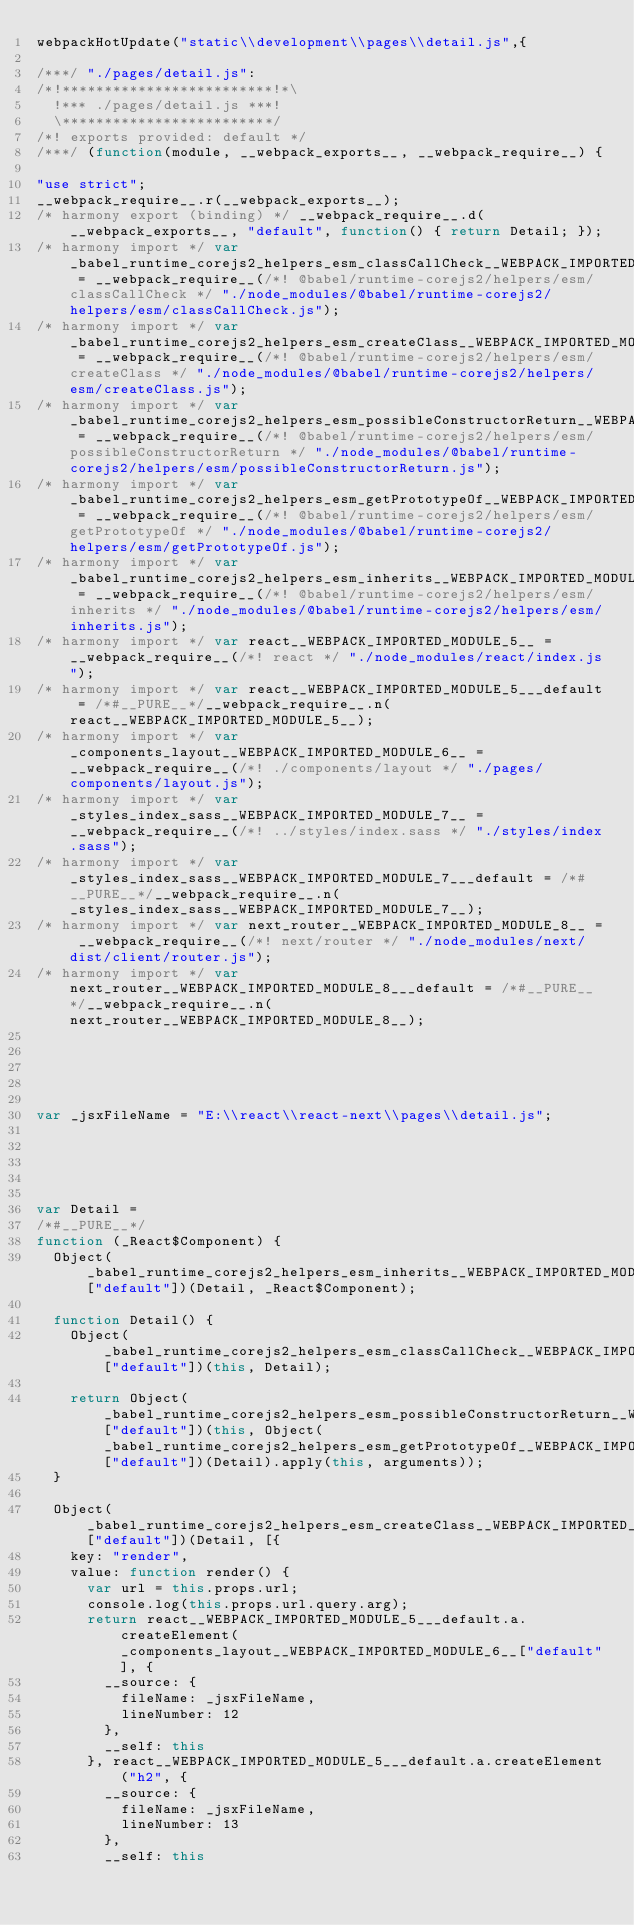<code> <loc_0><loc_0><loc_500><loc_500><_JavaScript_>webpackHotUpdate("static\\development\\pages\\detail.js",{

/***/ "./pages/detail.js":
/*!*************************!*\
  !*** ./pages/detail.js ***!
  \*************************/
/*! exports provided: default */
/***/ (function(module, __webpack_exports__, __webpack_require__) {

"use strict";
__webpack_require__.r(__webpack_exports__);
/* harmony export (binding) */ __webpack_require__.d(__webpack_exports__, "default", function() { return Detail; });
/* harmony import */ var _babel_runtime_corejs2_helpers_esm_classCallCheck__WEBPACK_IMPORTED_MODULE_0__ = __webpack_require__(/*! @babel/runtime-corejs2/helpers/esm/classCallCheck */ "./node_modules/@babel/runtime-corejs2/helpers/esm/classCallCheck.js");
/* harmony import */ var _babel_runtime_corejs2_helpers_esm_createClass__WEBPACK_IMPORTED_MODULE_1__ = __webpack_require__(/*! @babel/runtime-corejs2/helpers/esm/createClass */ "./node_modules/@babel/runtime-corejs2/helpers/esm/createClass.js");
/* harmony import */ var _babel_runtime_corejs2_helpers_esm_possibleConstructorReturn__WEBPACK_IMPORTED_MODULE_2__ = __webpack_require__(/*! @babel/runtime-corejs2/helpers/esm/possibleConstructorReturn */ "./node_modules/@babel/runtime-corejs2/helpers/esm/possibleConstructorReturn.js");
/* harmony import */ var _babel_runtime_corejs2_helpers_esm_getPrototypeOf__WEBPACK_IMPORTED_MODULE_3__ = __webpack_require__(/*! @babel/runtime-corejs2/helpers/esm/getPrototypeOf */ "./node_modules/@babel/runtime-corejs2/helpers/esm/getPrototypeOf.js");
/* harmony import */ var _babel_runtime_corejs2_helpers_esm_inherits__WEBPACK_IMPORTED_MODULE_4__ = __webpack_require__(/*! @babel/runtime-corejs2/helpers/esm/inherits */ "./node_modules/@babel/runtime-corejs2/helpers/esm/inherits.js");
/* harmony import */ var react__WEBPACK_IMPORTED_MODULE_5__ = __webpack_require__(/*! react */ "./node_modules/react/index.js");
/* harmony import */ var react__WEBPACK_IMPORTED_MODULE_5___default = /*#__PURE__*/__webpack_require__.n(react__WEBPACK_IMPORTED_MODULE_5__);
/* harmony import */ var _components_layout__WEBPACK_IMPORTED_MODULE_6__ = __webpack_require__(/*! ./components/layout */ "./pages/components/layout.js");
/* harmony import */ var _styles_index_sass__WEBPACK_IMPORTED_MODULE_7__ = __webpack_require__(/*! ../styles/index.sass */ "./styles/index.sass");
/* harmony import */ var _styles_index_sass__WEBPACK_IMPORTED_MODULE_7___default = /*#__PURE__*/__webpack_require__.n(_styles_index_sass__WEBPACK_IMPORTED_MODULE_7__);
/* harmony import */ var next_router__WEBPACK_IMPORTED_MODULE_8__ = __webpack_require__(/*! next/router */ "./node_modules/next/dist/client/router.js");
/* harmony import */ var next_router__WEBPACK_IMPORTED_MODULE_8___default = /*#__PURE__*/__webpack_require__.n(next_router__WEBPACK_IMPORTED_MODULE_8__);





var _jsxFileName = "E:\\react\\react-next\\pages\\detail.js";





var Detail =
/*#__PURE__*/
function (_React$Component) {
  Object(_babel_runtime_corejs2_helpers_esm_inherits__WEBPACK_IMPORTED_MODULE_4__["default"])(Detail, _React$Component);

  function Detail() {
    Object(_babel_runtime_corejs2_helpers_esm_classCallCheck__WEBPACK_IMPORTED_MODULE_0__["default"])(this, Detail);

    return Object(_babel_runtime_corejs2_helpers_esm_possibleConstructorReturn__WEBPACK_IMPORTED_MODULE_2__["default"])(this, Object(_babel_runtime_corejs2_helpers_esm_getPrototypeOf__WEBPACK_IMPORTED_MODULE_3__["default"])(Detail).apply(this, arguments));
  }

  Object(_babel_runtime_corejs2_helpers_esm_createClass__WEBPACK_IMPORTED_MODULE_1__["default"])(Detail, [{
    key: "render",
    value: function render() {
      var url = this.props.url;
      console.log(this.props.url.query.arg);
      return react__WEBPACK_IMPORTED_MODULE_5___default.a.createElement(_components_layout__WEBPACK_IMPORTED_MODULE_6__["default"], {
        __source: {
          fileName: _jsxFileName,
          lineNumber: 12
        },
        __self: this
      }, react__WEBPACK_IMPORTED_MODULE_5___default.a.createElement("h2", {
        __source: {
          fileName: _jsxFileName,
          lineNumber: 13
        },
        __self: this</code> 